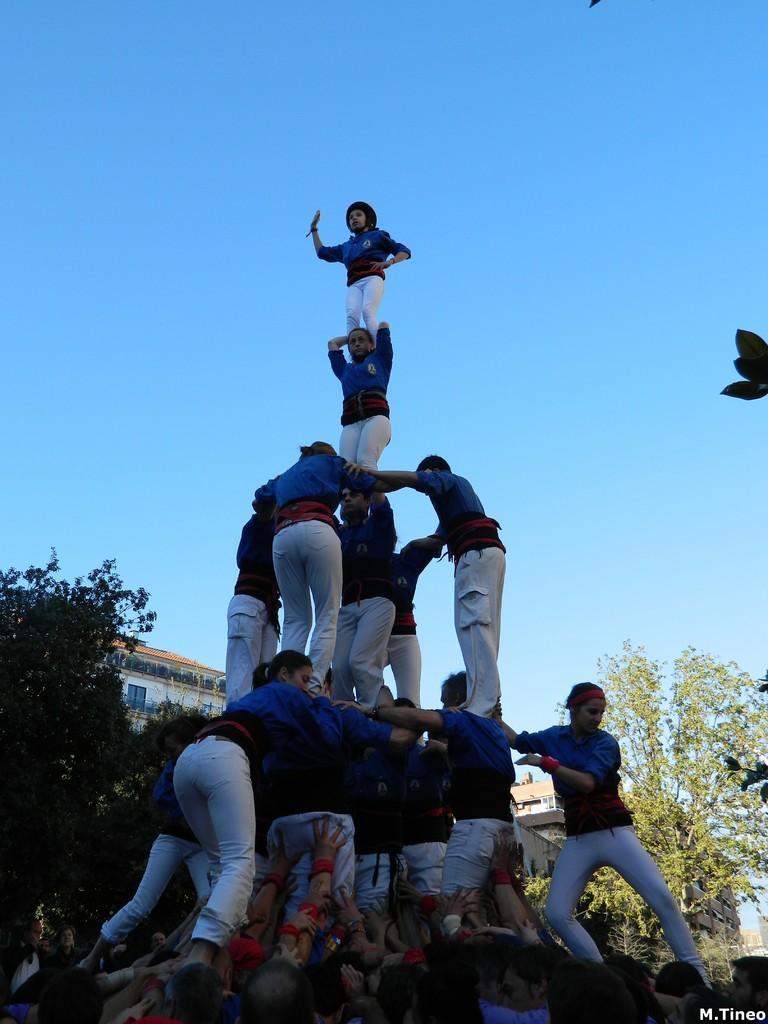Could you give a brief overview of what you see in this image? In this picture we can see a group of people standing in a circle. There is a text in the bottom right. We can see a few trees and buildings in the background. Sky is blue in color. 